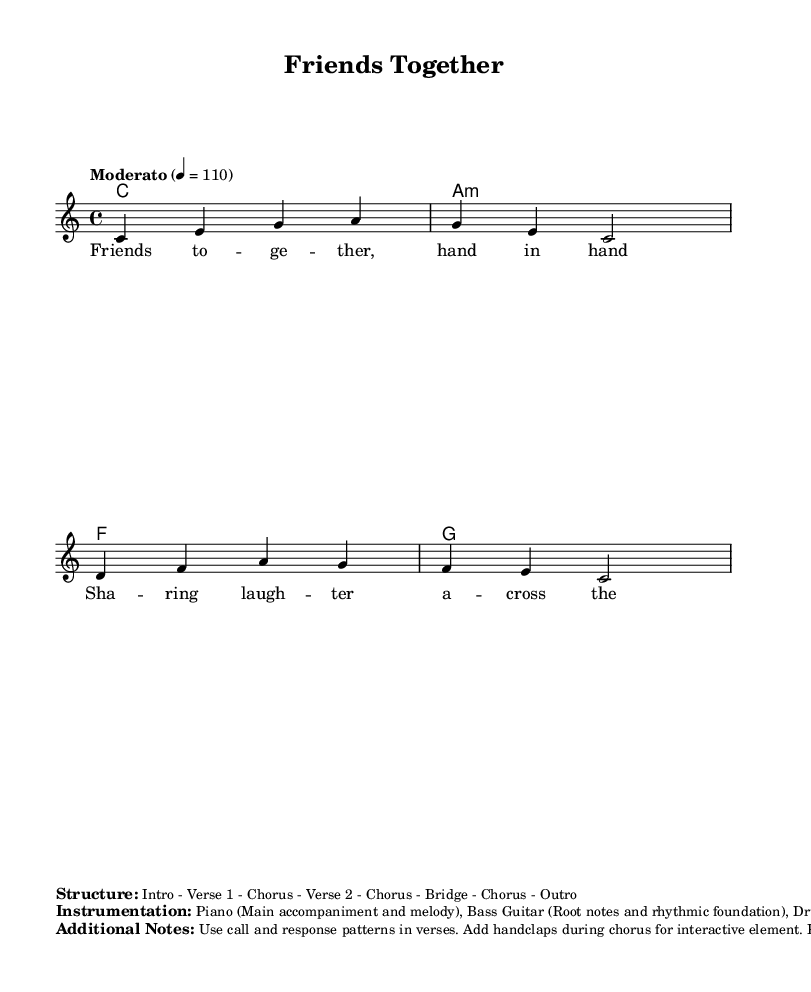What is the key signature of this music? The key signature is C major, which has no sharps or flats.
Answer: C major What is the time signature of the piece? The time signature is indicated at the beginning of the score, showing the number of beats in a measure. Here, it is 4 beats per measure.
Answer: 4/4 What is the tempo marking in the score? The tempo marking specifies the speed of the piece, noted at the start as "Moderato" with a metronome marking of quarter note equals 110.
Answer: Moderato 4 = 110 What instruments are included in the instrumentation for this piece? The score specifies the instruments to be used, which include Piano, Bass Guitar, Drums, and Tambourine.
Answer: Piano, Bass Guitar, Drums, Tambourine What type of musical texture is suggested for the verses? The additional notes suggest using a call and response pattern in the verses, indicating a collaborative and interactive texture.
Answer: Call and response How does the arrangement enhance participation? The score mentions adding handclaps during the chorus, making it an interactive element that encourages audience participation.
Answer: Handclaps 